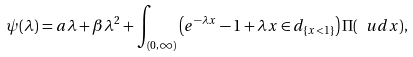Convert formula to latex. <formula><loc_0><loc_0><loc_500><loc_500>\psi ( \lambda ) = a \lambda + \beta \lambda ^ { 2 } + \int _ { ( 0 , \infty ) } \left ( e ^ { - \lambda x } - 1 + \lambda x \in d _ { \{ x < 1 \} } \right ) \Pi ( \ u d x ) ,</formula> 